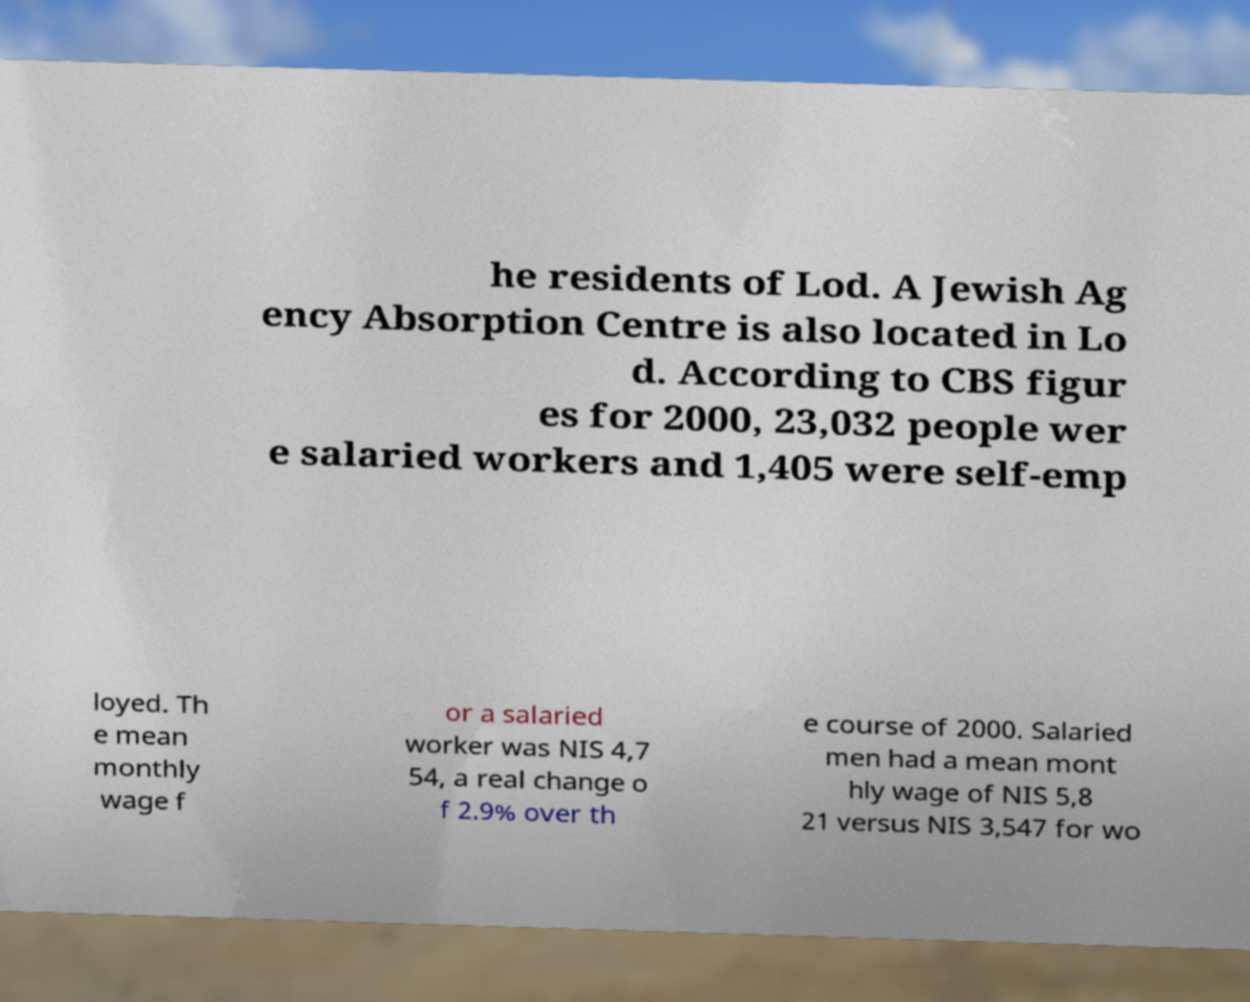Please read and relay the text visible in this image. What does it say? he residents of Lod. A Jewish Ag ency Absorption Centre is also located in Lo d. According to CBS figur es for 2000, 23,032 people wer e salaried workers and 1,405 were self-emp loyed. Th e mean monthly wage f or a salaried worker was NIS 4,7 54, a real change o f 2.9% over th e course of 2000. Salaried men had a mean mont hly wage of NIS 5,8 21 versus NIS 3,547 for wo 